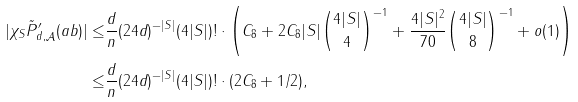<formula> <loc_0><loc_0><loc_500><loc_500>| \chi _ { S } \tilde { P } ^ { \prime } _ { d , \mathcal { A } } ( a b ) | \leq & \frac { d } { n } ( 2 4 d ) ^ { - | S | } ( 4 | S | ) ! \cdot \left ( C _ { 8 } + 2 C _ { 8 } | S | \binom { 4 | S | } { 4 } ^ { - 1 } + \frac { 4 | S | ^ { 2 } } { 7 0 } \binom { 4 | S | } { 8 } ^ { - 1 } + o ( 1 ) \right ) \\ \leq & \frac { d } { n } ( 2 4 d ) ^ { - | S | } ( 4 | S | ) ! \cdot ( 2 C _ { 8 } + 1 / 2 ) ,</formula> 